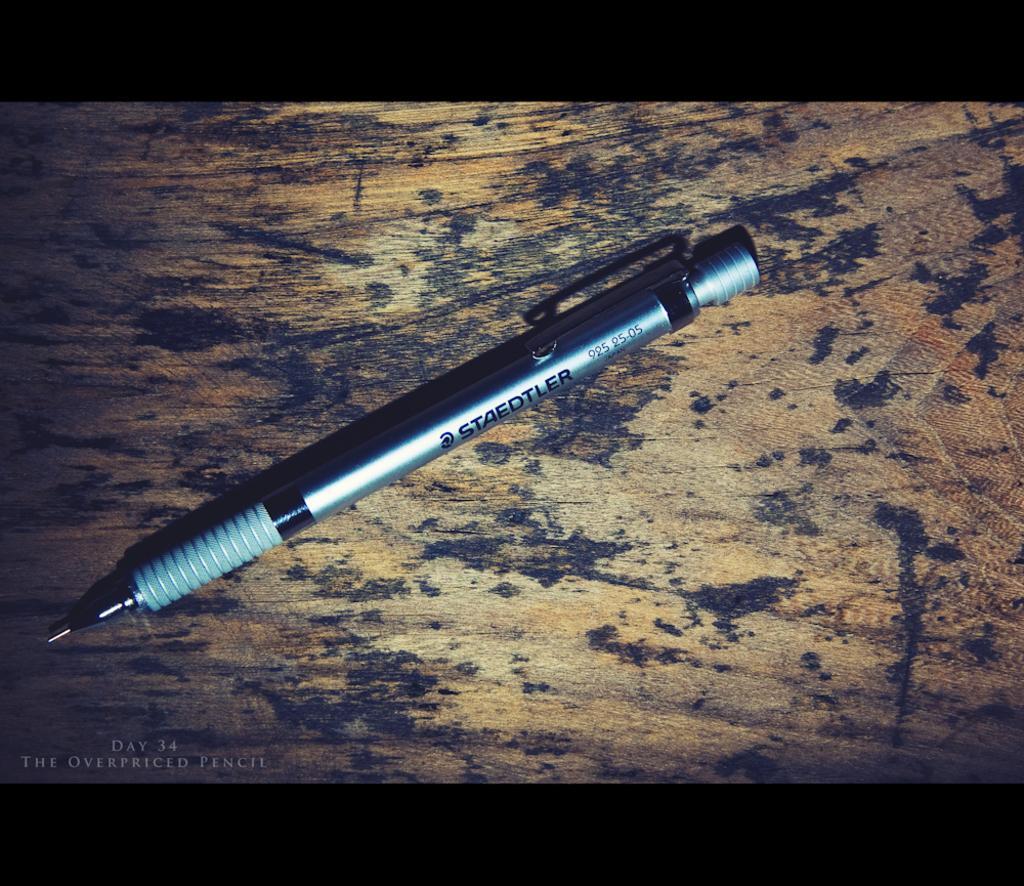In one or two sentences, can you explain what this image depicts? In this picture there is a pen in the center of the image on a table. 